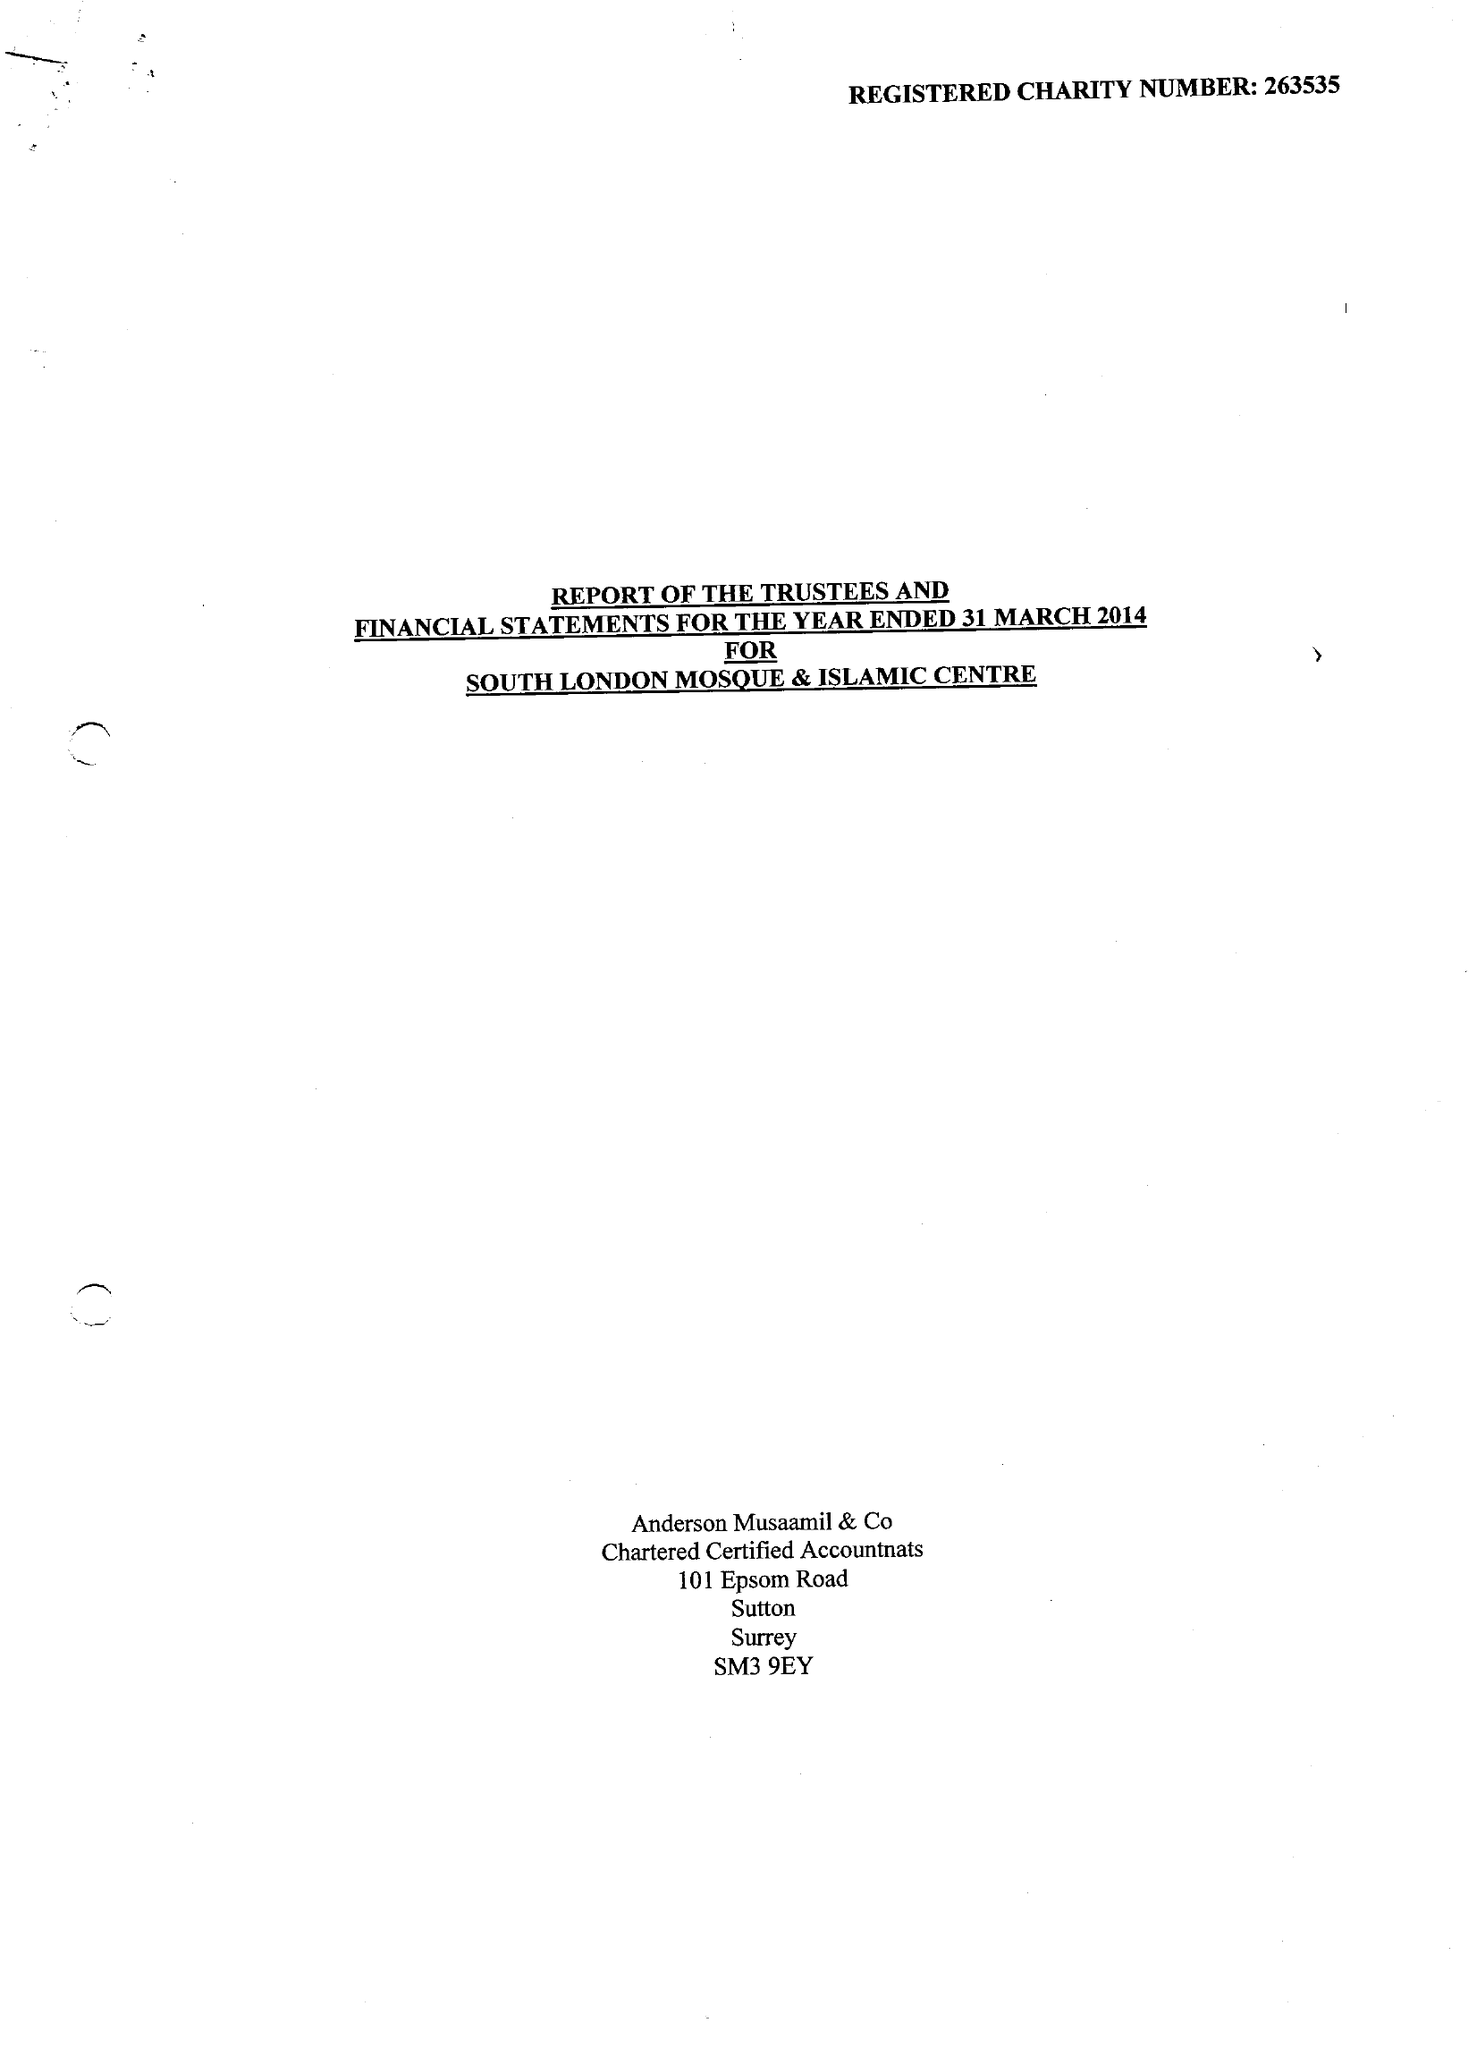What is the value for the income_annually_in_british_pounds?
Answer the question using a single word or phrase. 368132.00 